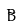<formula> <loc_0><loc_0><loc_500><loc_500>\tilde { B }</formula> 